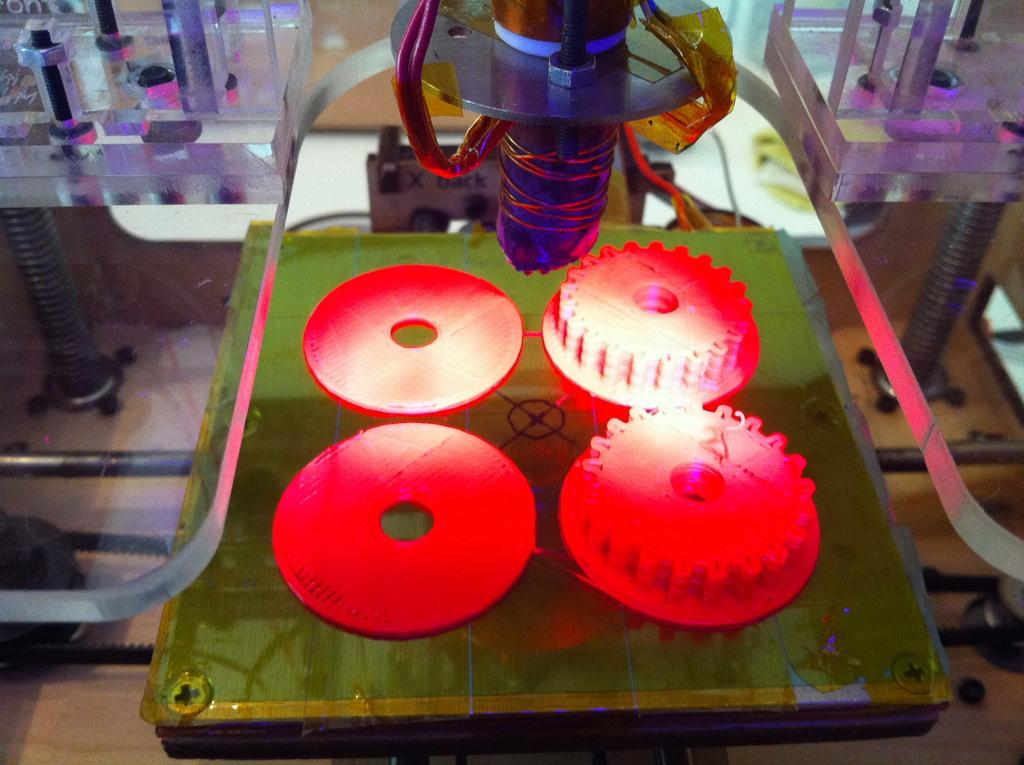What color can be seen on the objects in the image? There are red color objects in the image. What is the color of the surface on which the red objects are placed? The red objects are on a green color surface. What type of material is visible on both sides of the image? There are glass elements on both sides of the image. What can be seen at the top of the image? There is a machine visible at the top of the image. What type of advertisement is displayed on the orange surface in the image? There is no orange surface or advertisement present in the image. 